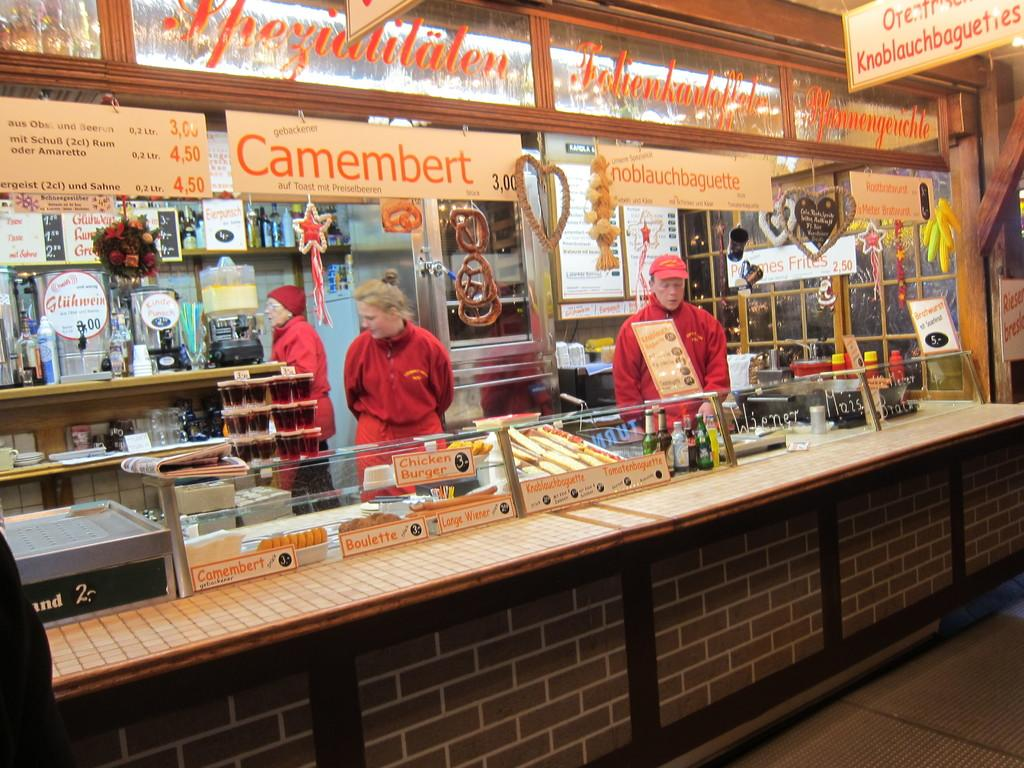<image>
Give a short and clear explanation of the subsequent image. Person standing behind a stall that says "noblauchbaguette" on it. 